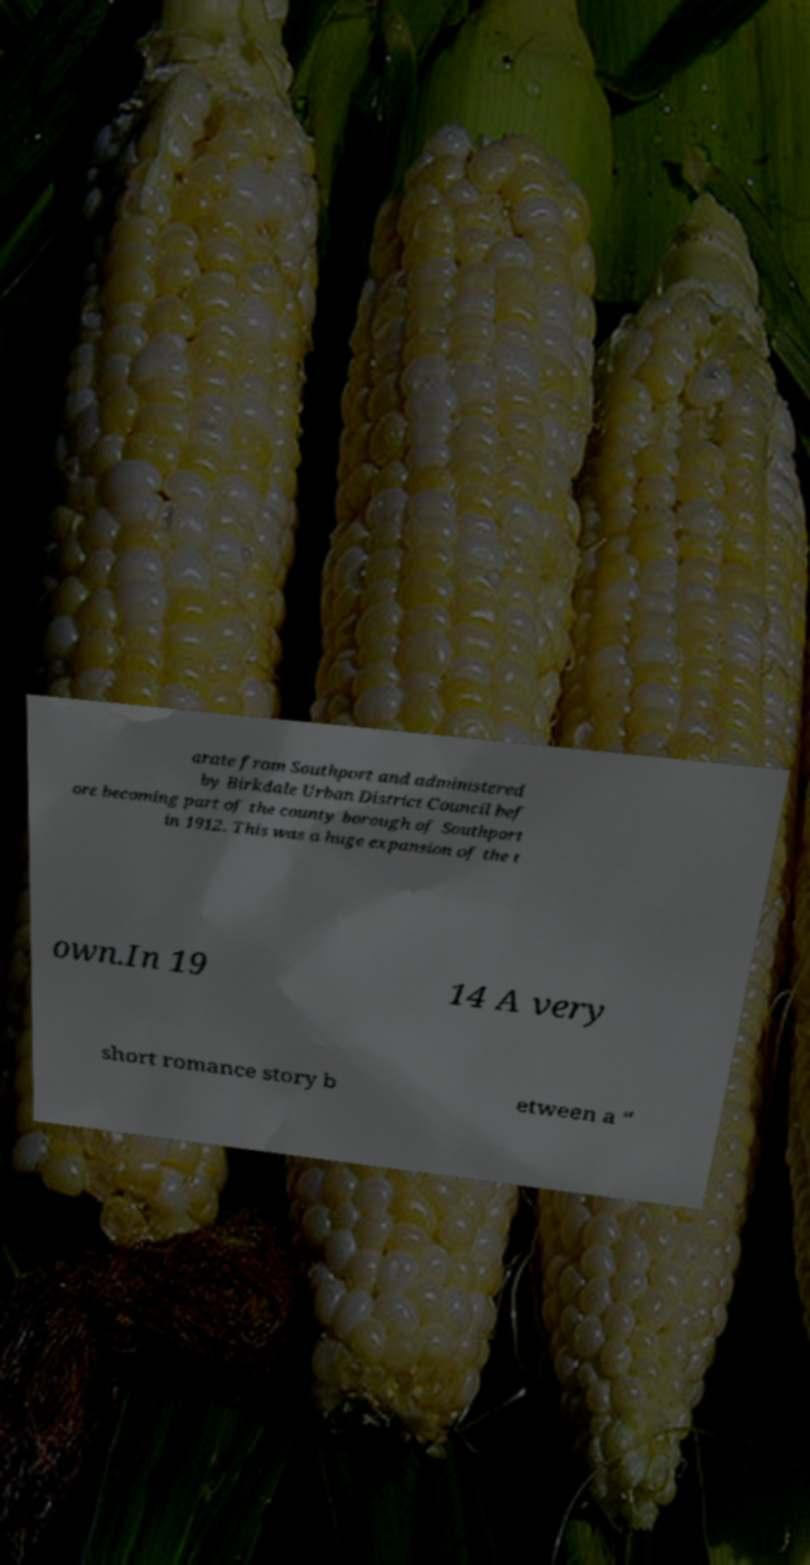Please read and relay the text visible in this image. What does it say? arate from Southport and administered by Birkdale Urban District Council bef ore becoming part of the county borough of Southport in 1912. This was a huge expansion of the t own.In 19 14 A very short romance story b etween a “ 